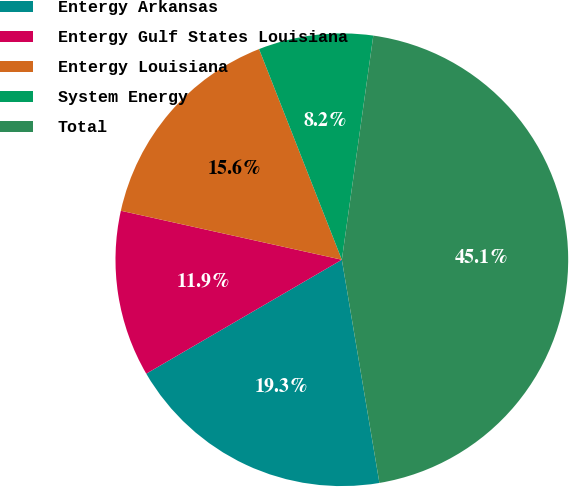Convert chart. <chart><loc_0><loc_0><loc_500><loc_500><pie_chart><fcel>Entergy Arkansas<fcel>Entergy Gulf States Louisiana<fcel>Entergy Louisiana<fcel>System Energy<fcel>Total<nl><fcel>19.26%<fcel>11.87%<fcel>15.57%<fcel>8.18%<fcel>45.13%<nl></chart> 